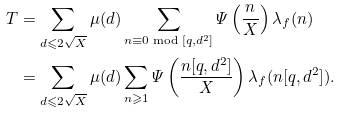Convert formula to latex. <formula><loc_0><loc_0><loc_500><loc_500>T & = \sum _ { d \leqslant 2 \sqrt { X } } \mu ( d ) \sum _ { n \equiv 0 \bmod { [ q , d ^ { 2 } ] } } \varPsi \left ( \frac { n } { X } \right ) \lambda _ { f } ( n ) \\ & = \sum _ { d \leqslant 2 \sqrt { X } } \mu ( d ) \sum _ { n \geqslant 1 } \varPsi \left ( \frac { n [ q , d ^ { 2 } ] } { X } \right ) \lambda _ { f } ( n [ q , d ^ { 2 } ] ) .</formula> 